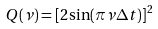Convert formula to latex. <formula><loc_0><loc_0><loc_500><loc_500>Q ( \nu ) = [ 2 \sin ( \pi \nu \Delta t ) ] ^ { 2 }</formula> 